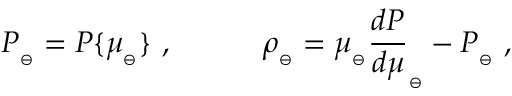Convert formula to latex. <formula><loc_0><loc_0><loc_500><loc_500>P _ { _ { \ominus } } = P \{ \mu _ { _ { \ominus } } \} \ , \quad \rho _ { _ { \ominus } } = \mu _ { _ { \ominus } } { \frac { d P } { d \mu } } _ { _ { \ominus } } - P _ { _ { \ominus } } \ ,</formula> 